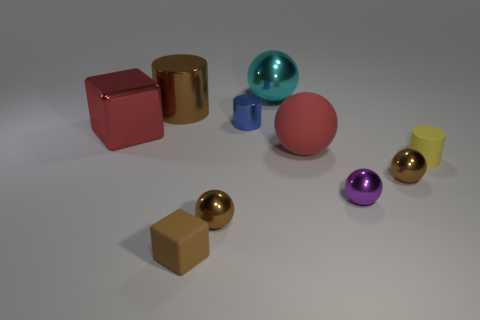Is the number of brown things that are on the right side of the tiny blue metal object greater than the number of matte cubes that are behind the tiny yellow rubber cylinder?
Offer a terse response. Yes. The small brown object that is made of the same material as the yellow cylinder is what shape?
Your answer should be compact. Cube. There is a cube that is made of the same material as the brown cylinder; what color is it?
Ensure brevity in your answer.  Red. What number of other things are there of the same color as the small block?
Your response must be concise. 3. Is there any other thing that is the same size as the red metal object?
Your answer should be compact. Yes. There is a red thing right of the red cube; is it the same shape as the small matte object on the right side of the blue object?
Your answer should be compact. No. The brown thing that is the same size as the red rubber ball is what shape?
Offer a very short reply. Cylinder. Are there the same number of cylinders in front of the large metal cylinder and brown cylinders that are in front of the small brown rubber block?
Give a very brief answer. No. Is there anything else that is the same shape as the yellow matte thing?
Offer a terse response. Yes. Are the cylinder in front of the red shiny cube and the small purple object made of the same material?
Make the answer very short. No. 